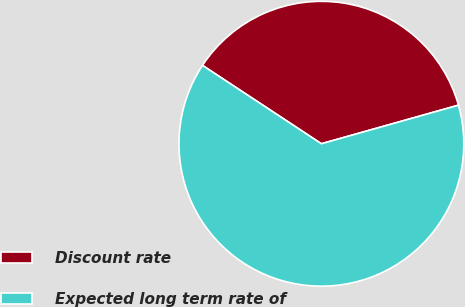Convert chart. <chart><loc_0><loc_0><loc_500><loc_500><pie_chart><fcel>Discount rate<fcel>Expected long term rate of<nl><fcel>36.36%<fcel>63.64%<nl></chart> 